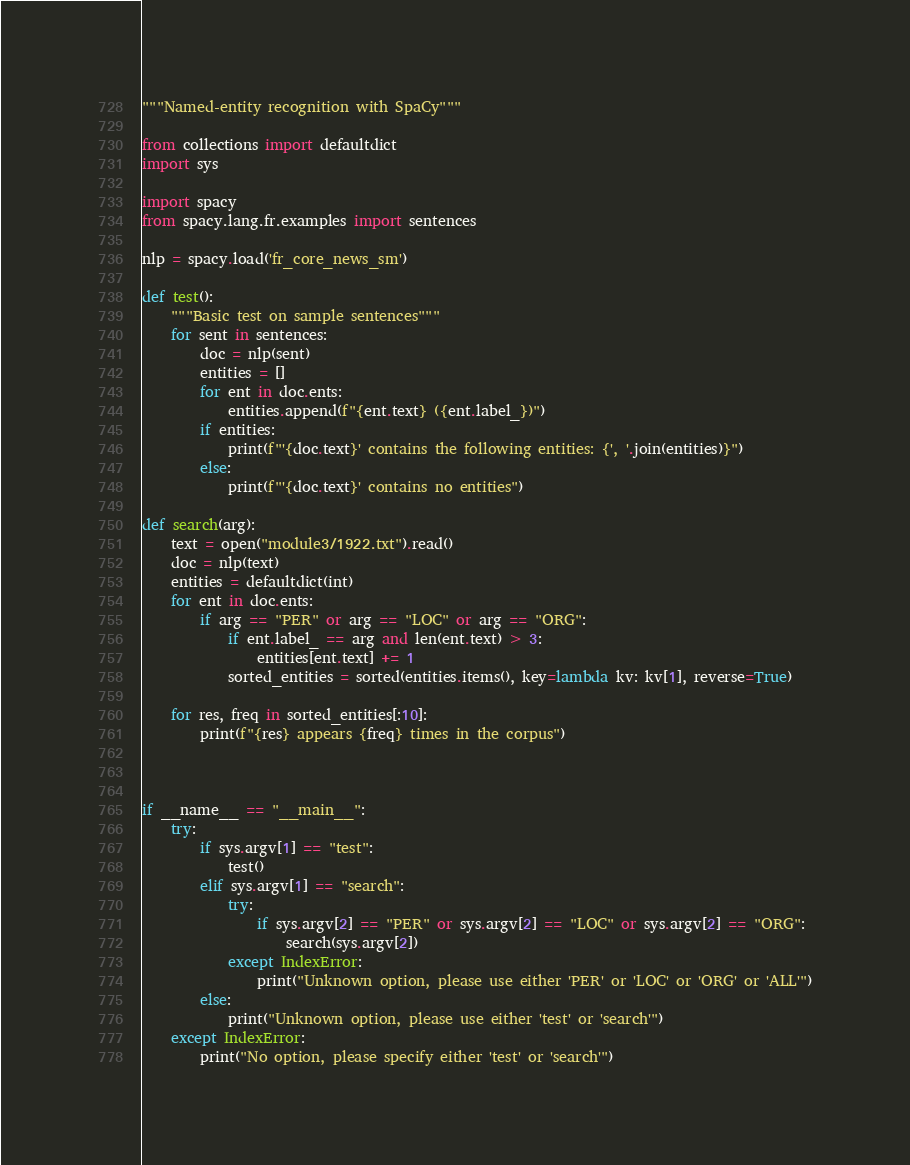Convert code to text. <code><loc_0><loc_0><loc_500><loc_500><_Python_>"""Named-entity recognition with SpaCy"""

from collections import defaultdict
import sys

import spacy
from spacy.lang.fr.examples import sentences

nlp = spacy.load('fr_core_news_sm')

def test():
    """Basic test on sample sentences"""
    for sent in sentences:
        doc = nlp(sent)
        entities = []
        for ent in doc.ents:
            entities.append(f"{ent.text} ({ent.label_})")
        if entities:
            print(f"'{doc.text}' contains the following entities: {', '.join(entities)}")
        else:
            print(f"'{doc.text}' contains no entities")

def search(arg):
    text = open("module3/1922.txt").read()
    doc = nlp(text)
    entities = defaultdict(int)
    for ent in doc.ents:
        if arg == "PER" or arg == "LOC" or arg == "ORG":
            if ent.label_ == arg and len(ent.text) > 3:
                entities[ent.text] += 1
            sorted_entities = sorted(entities.items(), key=lambda kv: kv[1], reverse=True)

    for res, freq in sorted_entities[:10]:
        print(f"{res} appears {freq} times in the corpus")



if __name__ == "__main__":
    try:
        if sys.argv[1] == "test":
            test()
        elif sys.argv[1] == "search":
            try:
                if sys.argv[2] == "PER" or sys.argv[2] == "LOC" or sys.argv[2] == "ORG":
                    search(sys.argv[2])
            except IndexError:
                print("Unknown option, please use either 'PER' or 'LOC' or 'ORG' or 'ALL'")
        else:
            print("Unknown option, please use either 'test' or 'search'")
    except IndexError:
        print("No option, please specify either 'test' or 'search'")
</code> 